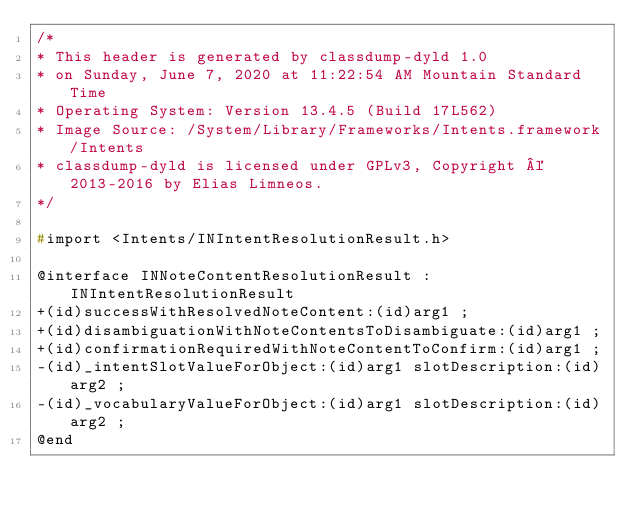Convert code to text. <code><loc_0><loc_0><loc_500><loc_500><_C_>/*
* This header is generated by classdump-dyld 1.0
* on Sunday, June 7, 2020 at 11:22:54 AM Mountain Standard Time
* Operating System: Version 13.4.5 (Build 17L562)
* Image Source: /System/Library/Frameworks/Intents.framework/Intents
* classdump-dyld is licensed under GPLv3, Copyright © 2013-2016 by Elias Limneos.
*/

#import <Intents/INIntentResolutionResult.h>

@interface INNoteContentResolutionResult : INIntentResolutionResult
+(id)successWithResolvedNoteContent:(id)arg1 ;
+(id)disambiguationWithNoteContentsToDisambiguate:(id)arg1 ;
+(id)confirmationRequiredWithNoteContentToConfirm:(id)arg1 ;
-(id)_intentSlotValueForObject:(id)arg1 slotDescription:(id)arg2 ;
-(id)_vocabularyValueForObject:(id)arg1 slotDescription:(id)arg2 ;
@end

</code> 